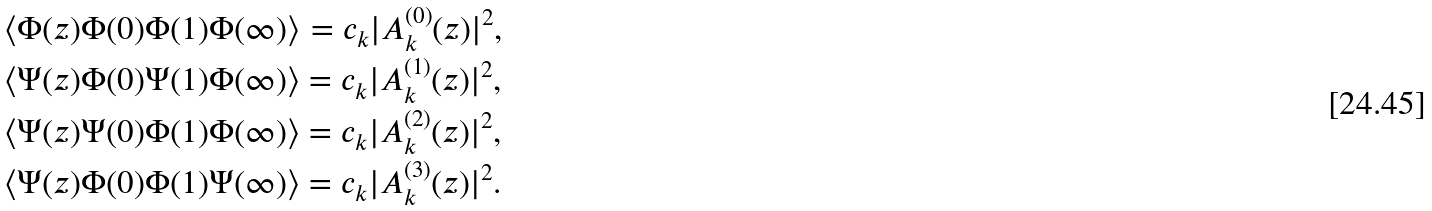Convert formula to latex. <formula><loc_0><loc_0><loc_500><loc_500>& \langle \Phi ( z ) \Phi ( 0 ) \Phi ( 1 ) \Phi ( \infty ) \rangle = c _ { k } | A _ { k } ^ { ( 0 ) } ( z ) | ^ { 2 } , \\ & \langle \Psi ( z ) \Phi ( 0 ) \Psi ( 1 ) \Phi ( \infty ) \rangle = c _ { k } | A _ { k } ^ { ( 1 ) } ( z ) | ^ { 2 } , \\ & \langle \Psi ( z ) \Psi ( 0 ) \Phi ( 1 ) \Phi ( \infty ) \rangle = c _ { k } | A _ { k } ^ { ( 2 ) } ( z ) | ^ { 2 } , \ \\ & \langle \Psi ( z ) \Phi ( 0 ) \Phi ( 1 ) \Psi ( \infty ) \rangle = c _ { k } | A _ { k } ^ { ( 3 ) } ( z ) | ^ { 2 } .</formula> 